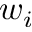Convert formula to latex. <formula><loc_0><loc_0><loc_500><loc_500>w _ { i }</formula> 